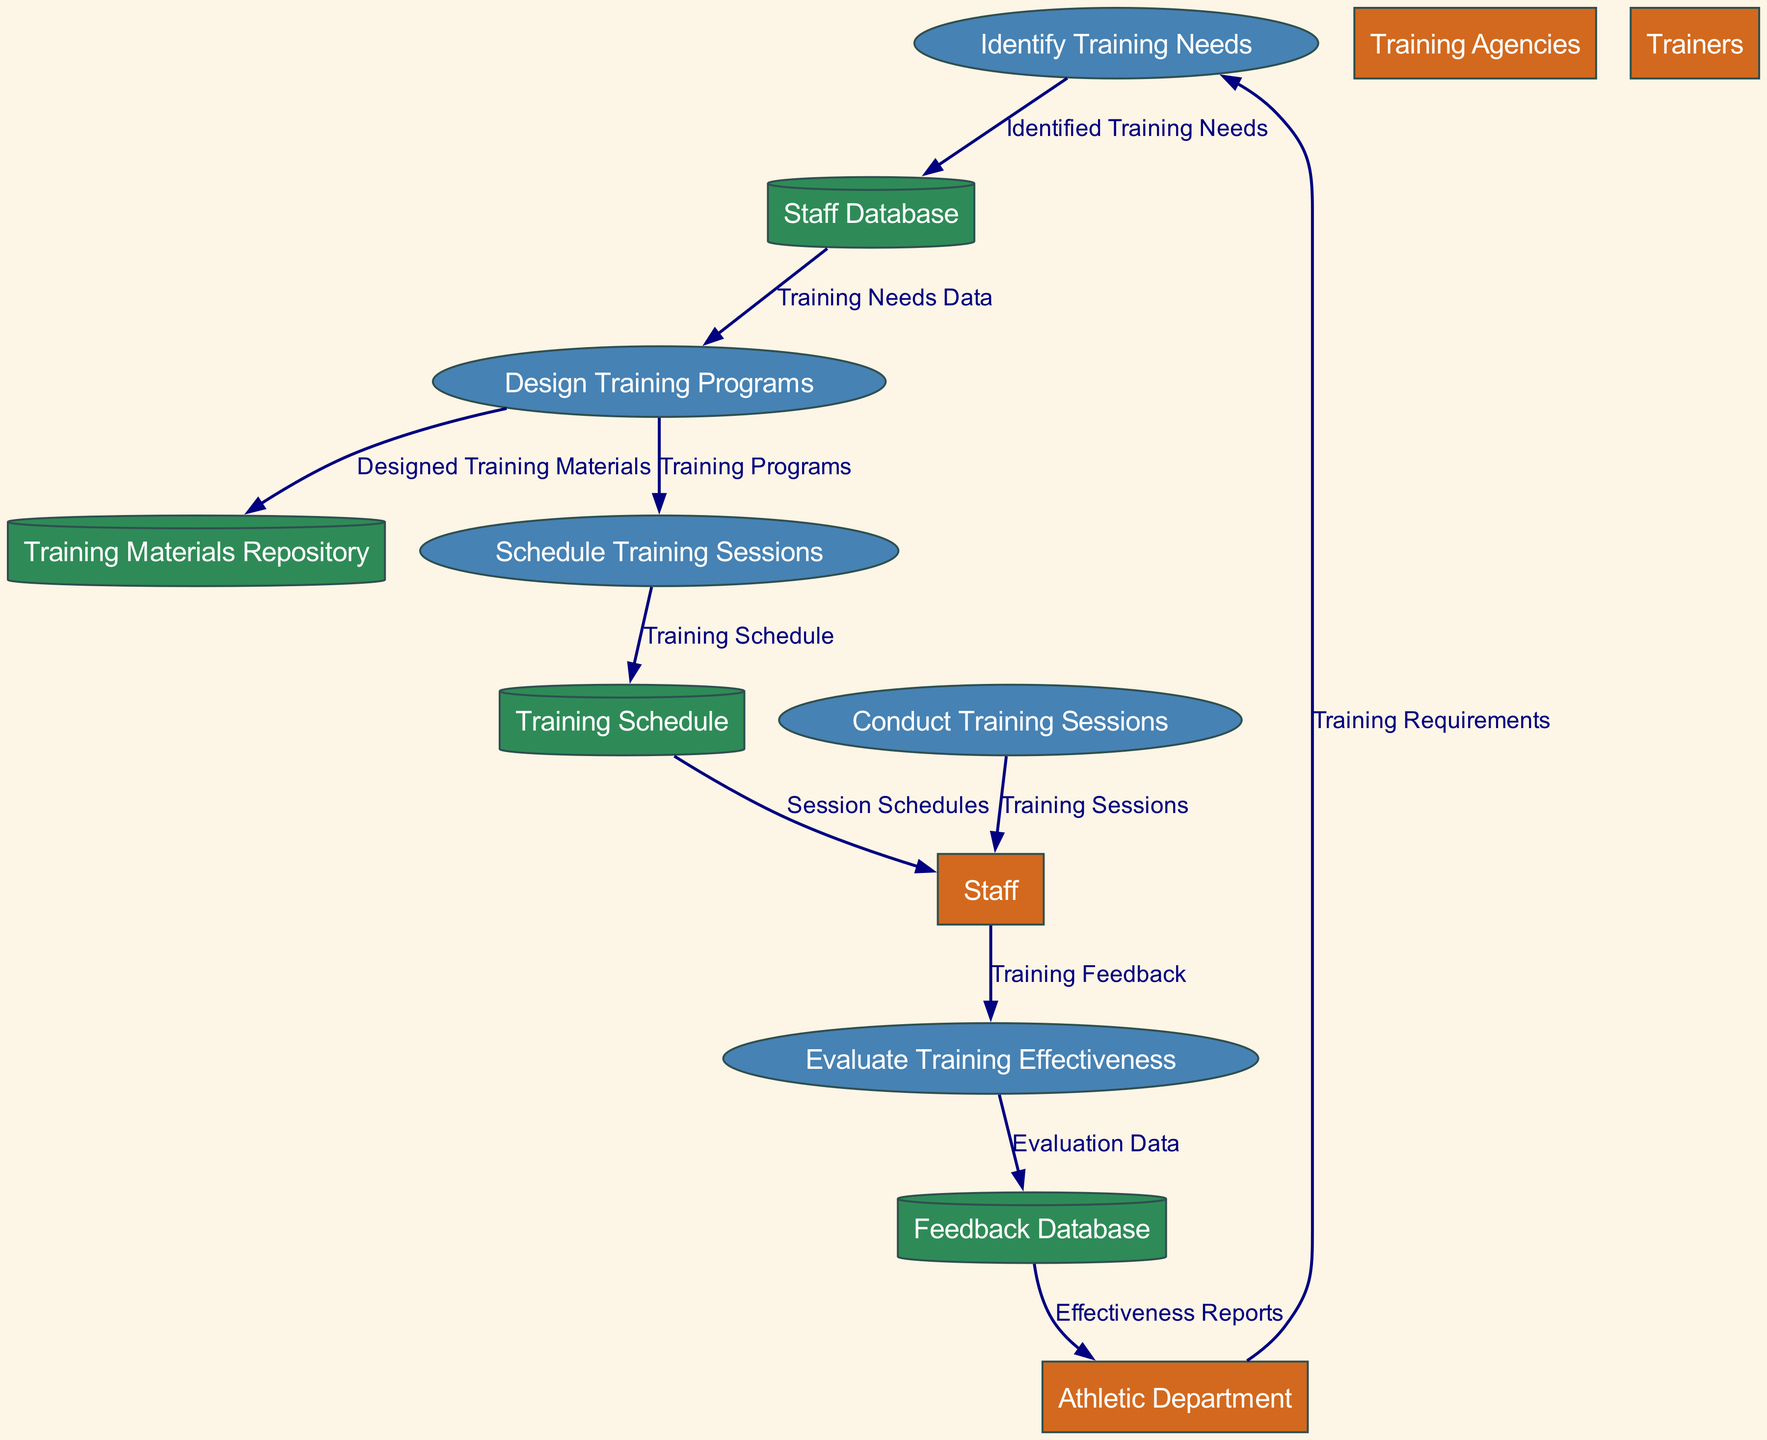What is the first process in the diagram? The first process in the diagram is "Identify Training Needs," which is represented as the initial step in the flow of training coordination.
Answer: Identify Training Needs How many data stores are there? The diagram contains four data stores: Staff Database, Training Materials Repository, Training Schedule, and Feedback Database. Count each of these to reach the total.
Answer: 4 Who provides the training requirements? The external entity "Athletic Department" provides the "Training Requirements" to the first process, indicating its role in initiating the training needs assessment.
Answer: Athletic Department What is the output of the "Conduct Training Sessions" process? The output of the "Conduct Training Sessions" process is "Training Sessions," which are delivered to the staff. This indicates that these sessions are the result of conducting training.
Answer: Training Sessions Which process receives feedback from the staff? The process "Evaluate Training Effectiveness" receives feedback from the staff, indicating that this feedback is crucial for assessing how effective the training sessions were.
Answer: Evaluate Training Effectiveness Which data store contains the evaluation results? The "Feedback Database" is where the evaluation results are stored, capturing data related to the effectiveness of the training as provided after sessions are conducted.
Answer: Feedback Database How does the training feedback reach the effectiveness evaluation? The training feedback is provided by the "Staff" to the "Evaluate Training Effectiveness" process, signifying that staff input is essential for determining the program’s success.
Answer: Through the Evaluate Training Effectiveness process What does the "Training Schedule" data store provide to the staff? The "Training Schedule" data store provides "Session Schedules" to the staff, which helps them understand when and where training sessions are taking place.
Answer: Session Schedules How many processes are involved in the diagram? There are five processes involved in the diagram, which are: Identify Training Needs, Design Training Programs, Schedule Training Sessions, Conduct Training Sessions, and Evaluate Training Effectiveness.
Answer: 5 